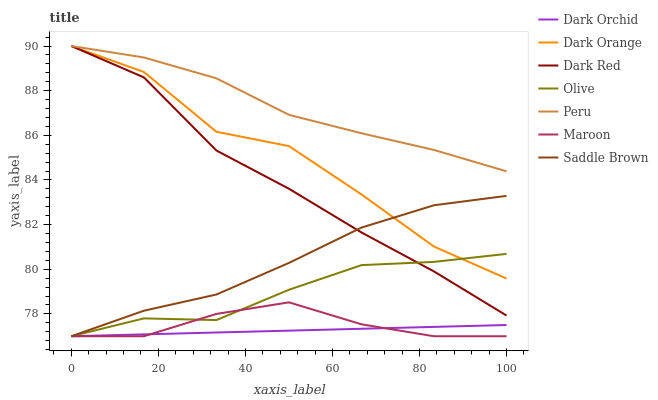Does Dark Orchid have the minimum area under the curve?
Answer yes or no. Yes. Does Peru have the maximum area under the curve?
Answer yes or no. Yes. Does Dark Red have the minimum area under the curve?
Answer yes or no. No. Does Dark Red have the maximum area under the curve?
Answer yes or no. No. Is Dark Orchid the smoothest?
Answer yes or no. Yes. Is Dark Orange the roughest?
Answer yes or no. Yes. Is Dark Red the smoothest?
Answer yes or no. No. Is Dark Red the roughest?
Answer yes or no. No. Does Maroon have the lowest value?
Answer yes or no. Yes. Does Dark Red have the lowest value?
Answer yes or no. No. Does Peru have the highest value?
Answer yes or no. Yes. Does Maroon have the highest value?
Answer yes or no. No. Is Dark Orchid less than Dark Red?
Answer yes or no. Yes. Is Peru greater than Olive?
Answer yes or no. Yes. Does Dark Orange intersect Saddle Brown?
Answer yes or no. Yes. Is Dark Orange less than Saddle Brown?
Answer yes or no. No. Is Dark Orange greater than Saddle Brown?
Answer yes or no. No. Does Dark Orchid intersect Dark Red?
Answer yes or no. No. 